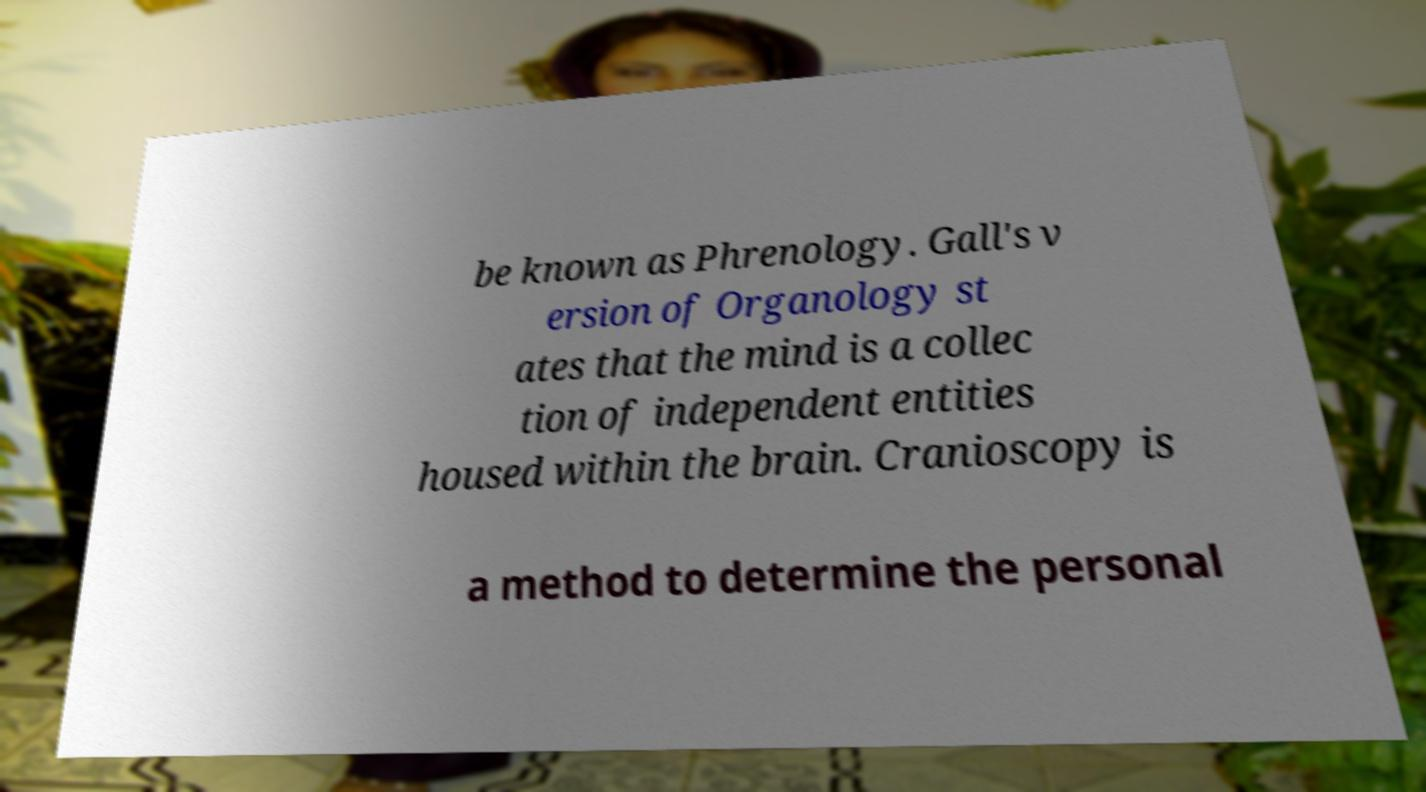Could you assist in decoding the text presented in this image and type it out clearly? be known as Phrenology. Gall's v ersion of Organology st ates that the mind is a collec tion of independent entities housed within the brain. Cranioscopy is a method to determine the personal 